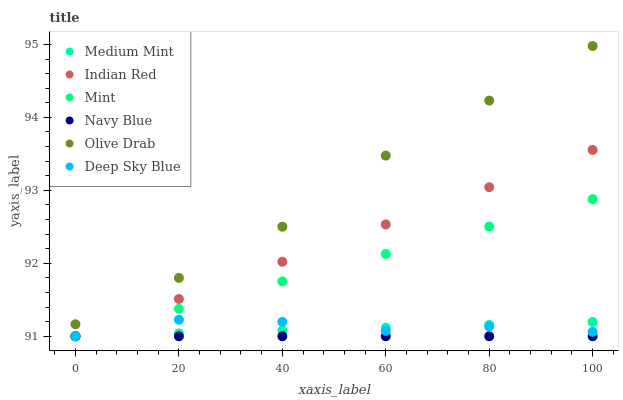Does Navy Blue have the minimum area under the curve?
Answer yes or no. Yes. Does Olive Drab have the maximum area under the curve?
Answer yes or no. Yes. Does Deep Sky Blue have the minimum area under the curve?
Answer yes or no. No. Does Deep Sky Blue have the maximum area under the curve?
Answer yes or no. No. Is Navy Blue the smoothest?
Answer yes or no. Yes. Is Deep Sky Blue the roughest?
Answer yes or no. Yes. Is Deep Sky Blue the smoothest?
Answer yes or no. No. Is Navy Blue the roughest?
Answer yes or no. No. Does Medium Mint have the lowest value?
Answer yes or no. Yes. Does Olive Drab have the lowest value?
Answer yes or no. No. Does Olive Drab have the highest value?
Answer yes or no. Yes. Does Deep Sky Blue have the highest value?
Answer yes or no. No. Is Mint less than Olive Drab?
Answer yes or no. Yes. Is Olive Drab greater than Indian Red?
Answer yes or no. Yes. Does Mint intersect Deep Sky Blue?
Answer yes or no. Yes. Is Mint less than Deep Sky Blue?
Answer yes or no. No. Is Mint greater than Deep Sky Blue?
Answer yes or no. No. Does Mint intersect Olive Drab?
Answer yes or no. No. 